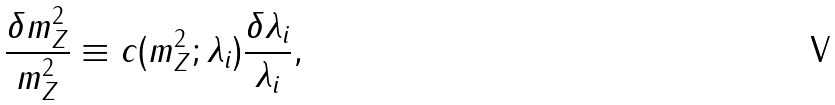<formula> <loc_0><loc_0><loc_500><loc_500>\frac { \delta m ^ { 2 } _ { Z } } { m ^ { 2 } _ { Z } } \equiv c ( m ^ { 2 } _ { Z } ; \lambda _ { i } ) \frac { \delta \lambda _ { i } } { \lambda _ { i } } ,</formula> 